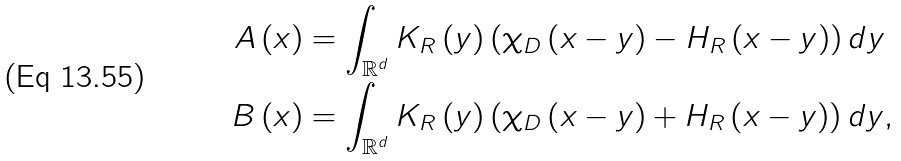Convert formula to latex. <formula><loc_0><loc_0><loc_500><loc_500>A \left ( x \right ) & = \int _ { \mathbb { R } ^ { d } } K _ { R } \left ( y \right ) \left ( \chi _ { D } \left ( x - y \right ) - H _ { R } \left ( x - y \right ) \right ) d y \\ B \left ( x \right ) & = \int _ { \mathbb { R } ^ { d } } K _ { R } \left ( y \right ) \left ( \chi _ { D } \left ( x - y \right ) + H _ { R } \left ( x - y \right ) \right ) d y ,</formula> 